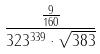Convert formula to latex. <formula><loc_0><loc_0><loc_500><loc_500>\frac { \frac { 9 } { 1 6 0 } } { 3 2 3 ^ { 3 3 9 } \cdot \sqrt { 3 8 3 } }</formula> 